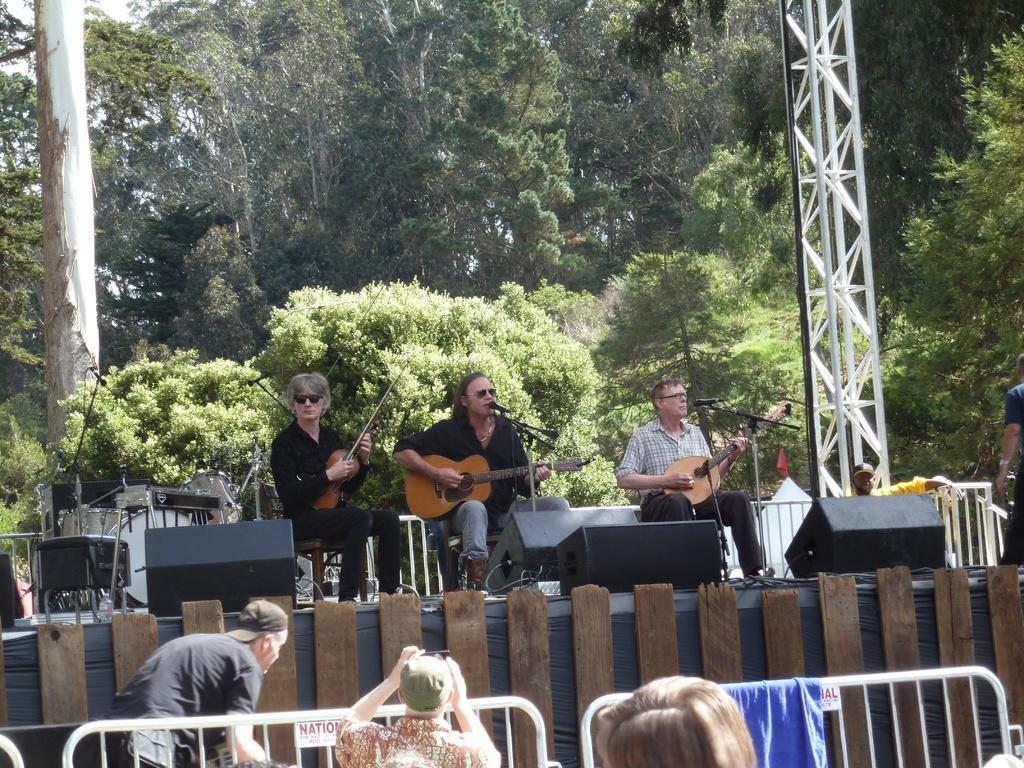Please provide a concise description of this image. Here we can see a group of people are sitting on the floor, and playing the guitar, and in front here is the microphone, and at back here are the trees. 